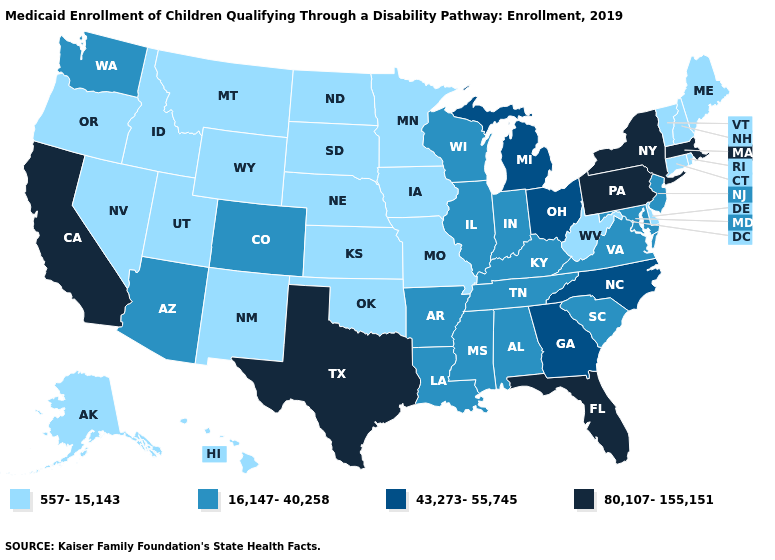Does Rhode Island have the lowest value in the USA?
Write a very short answer. Yes. What is the highest value in the USA?
Quick response, please. 80,107-155,151. What is the highest value in states that border Utah?
Give a very brief answer. 16,147-40,258. Does Montana have the highest value in the USA?
Keep it brief. No. What is the lowest value in the South?
Concise answer only. 557-15,143. Name the states that have a value in the range 80,107-155,151?
Be succinct. California, Florida, Massachusetts, New York, Pennsylvania, Texas. Among the states that border Tennessee , does North Carolina have the highest value?
Short answer required. Yes. Does Colorado have the lowest value in the West?
Write a very short answer. No. Name the states that have a value in the range 16,147-40,258?
Write a very short answer. Alabama, Arizona, Arkansas, Colorado, Illinois, Indiana, Kentucky, Louisiana, Maryland, Mississippi, New Jersey, South Carolina, Tennessee, Virginia, Washington, Wisconsin. Which states hav the highest value in the Northeast?
Concise answer only. Massachusetts, New York, Pennsylvania. Name the states that have a value in the range 557-15,143?
Quick response, please. Alaska, Connecticut, Delaware, Hawaii, Idaho, Iowa, Kansas, Maine, Minnesota, Missouri, Montana, Nebraska, Nevada, New Hampshire, New Mexico, North Dakota, Oklahoma, Oregon, Rhode Island, South Dakota, Utah, Vermont, West Virginia, Wyoming. Which states hav the highest value in the MidWest?
Write a very short answer. Michigan, Ohio. Does Pennsylvania have the highest value in the USA?
Give a very brief answer. Yes. What is the lowest value in the USA?
Short answer required. 557-15,143. What is the value of South Carolina?
Be succinct. 16,147-40,258. 